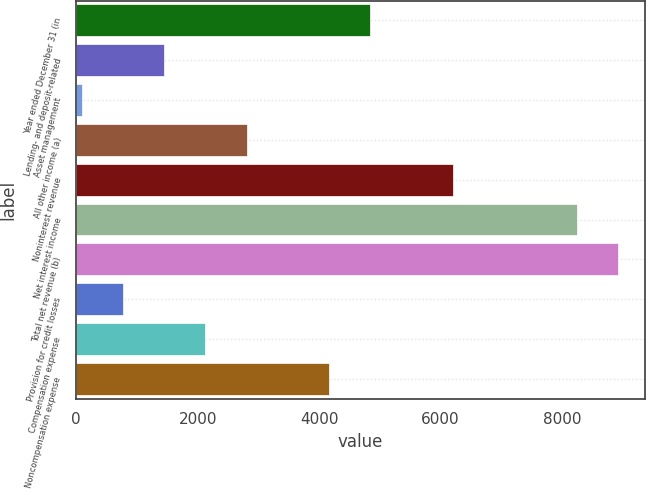<chart> <loc_0><loc_0><loc_500><loc_500><bar_chart><fcel>Year ended December 31 (in<fcel>Lending- and deposit-related<fcel>Asset management<fcel>All other income (a)<fcel>Noninterest revenue<fcel>Net interest income<fcel>Total net revenue (b)<fcel>Provision for credit losses<fcel>Compensation expense<fcel>Noncompensation expense<nl><fcel>4845.9<fcel>1447.4<fcel>88<fcel>2806.8<fcel>6205.3<fcel>8244.4<fcel>8924.1<fcel>767.7<fcel>2127.1<fcel>4166.2<nl></chart> 